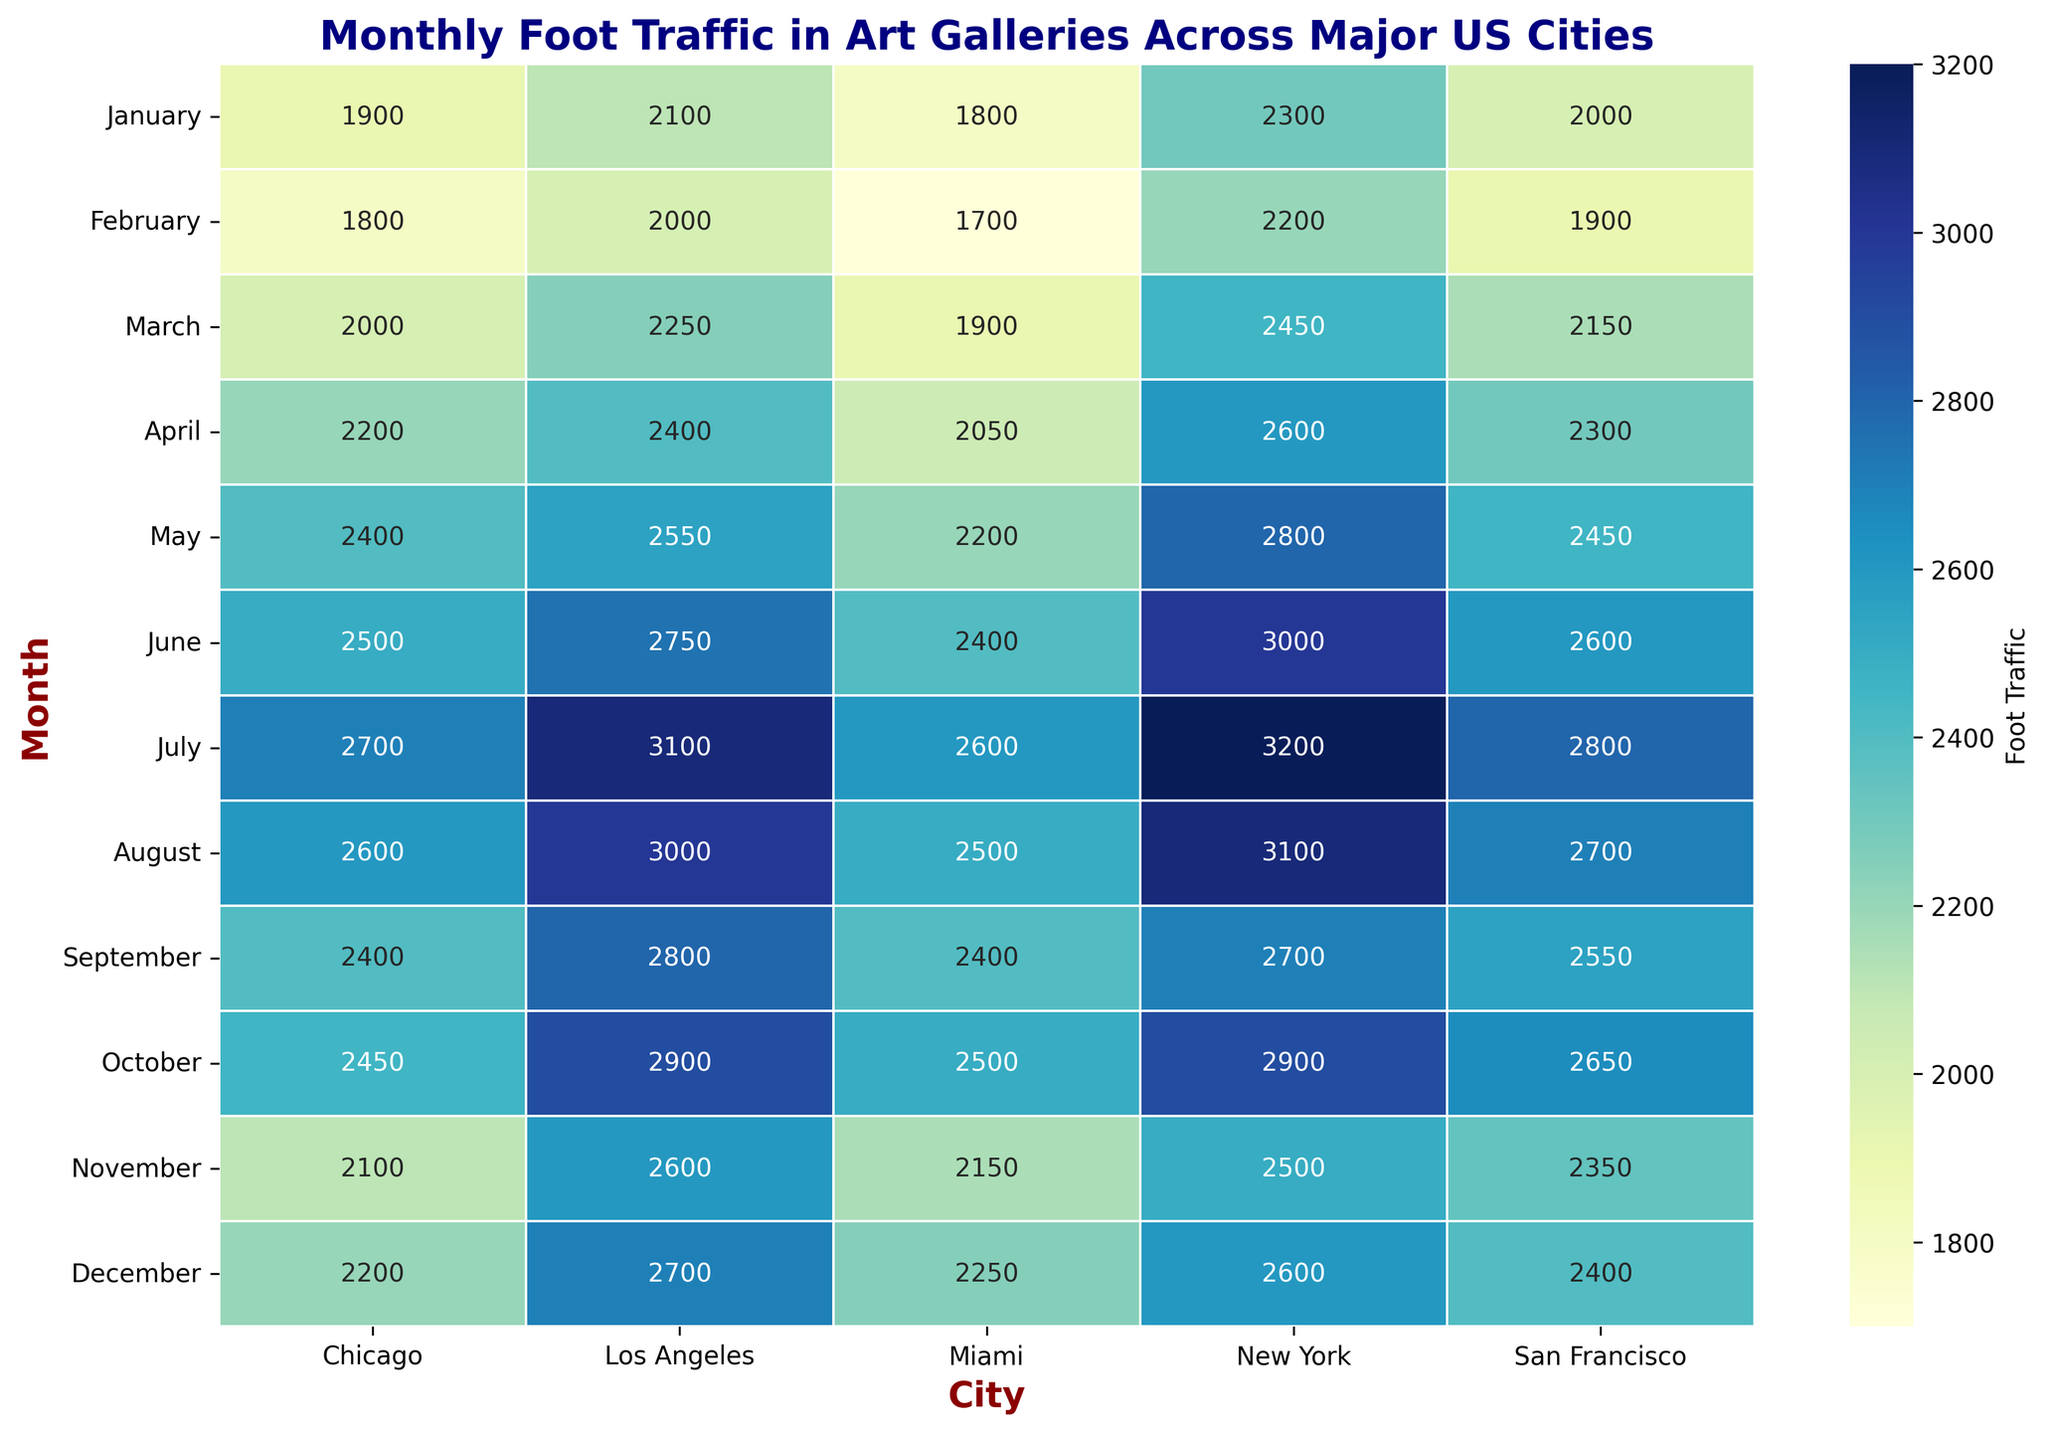Which city experienced the highest foot traffic in December? In the heatmap, look for the cell in the 'December' row with the highest value. It is 2700 for Los Angeles.
Answer: Los Angeles How many months did New York have a foot traffic higher than 3000 visitors? Check the values in New York's column and count the months with values over 3000 (June, July, August).
Answer: 3 Compare the foot traffic in July between New York and Chicago. Which has higher traffic? Locate July for both New York and Chicago, compare 3200 (New York) and 2700 (Chicago).
Answer: New York Does Miami have the lowest foot traffic in any month? Scan the entire heatmap for the lowest value. Miami's lowest is 1700 in February, which is indeed the lowest in the entire heatmap.
Answer: Yes What was the average foot traffic for Inspire Art in the first quarter (January - March)? Sum the traffic for January, February, and March for Inspire Art, then divide by 3: (2000 + 1900 + 2150) / 3 = 2016.67
Answer: 2016.67 Which city had the highest increase in foot traffic from January to December? Subtract the January values from the December values for each city and find the highest number.
Answer: Los Angeles Is there a month where all cities had foot traffic above 2000? Check each row to see if all values are above 2000. In June, all values are above 2000.
Answer: June During which month did Chicago see the lowest foot traffic? Identify the lowest value in Chicago's column. In Chicago, February has the lowest value (1800).
Answer: February Which city had more foot traffic in June, Los Angeles or San Francisco? Compare the value for June between Los Angeles (2750) and San Francisco (2600).
Answer: Los Angeles What is the total foot traffic for Vision Gallery over the year? Sum all the monthly values for Vision Gallery (Los Angeles): 2100 + 2000 + 2250 + 2400 + 2550 + 2750 + 3100 + 3000 + 2800 + 2900 + 2600 + 2700 = 34100
Answer: 34100 